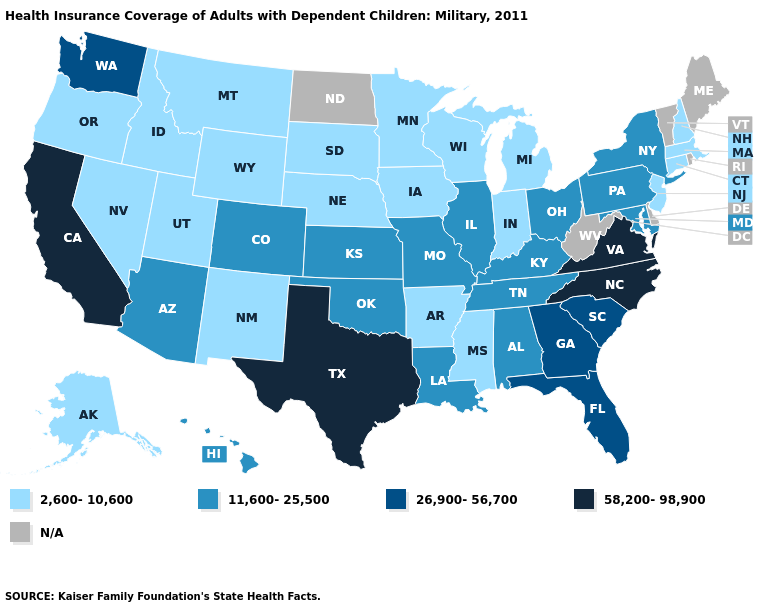Does the map have missing data?
Keep it brief. Yes. What is the value of West Virginia?
Write a very short answer. N/A. Name the states that have a value in the range 2,600-10,600?
Write a very short answer. Alaska, Arkansas, Connecticut, Idaho, Indiana, Iowa, Massachusetts, Michigan, Minnesota, Mississippi, Montana, Nebraska, Nevada, New Hampshire, New Jersey, New Mexico, Oregon, South Dakota, Utah, Wisconsin, Wyoming. Which states have the highest value in the USA?
Quick response, please. California, North Carolina, Texas, Virginia. Name the states that have a value in the range 2,600-10,600?
Answer briefly. Alaska, Arkansas, Connecticut, Idaho, Indiana, Iowa, Massachusetts, Michigan, Minnesota, Mississippi, Montana, Nebraska, Nevada, New Hampshire, New Jersey, New Mexico, Oregon, South Dakota, Utah, Wisconsin, Wyoming. Does North Carolina have the highest value in the USA?
Short answer required. Yes. Does Kansas have the lowest value in the MidWest?
Write a very short answer. No. What is the value of Wyoming?
Write a very short answer. 2,600-10,600. What is the value of Tennessee?
Keep it brief. 11,600-25,500. Does the map have missing data?
Concise answer only. Yes. Is the legend a continuous bar?
Be succinct. No. Does the map have missing data?
Quick response, please. Yes. What is the highest value in the West ?
Short answer required. 58,200-98,900. What is the value of Connecticut?
Be succinct. 2,600-10,600. 